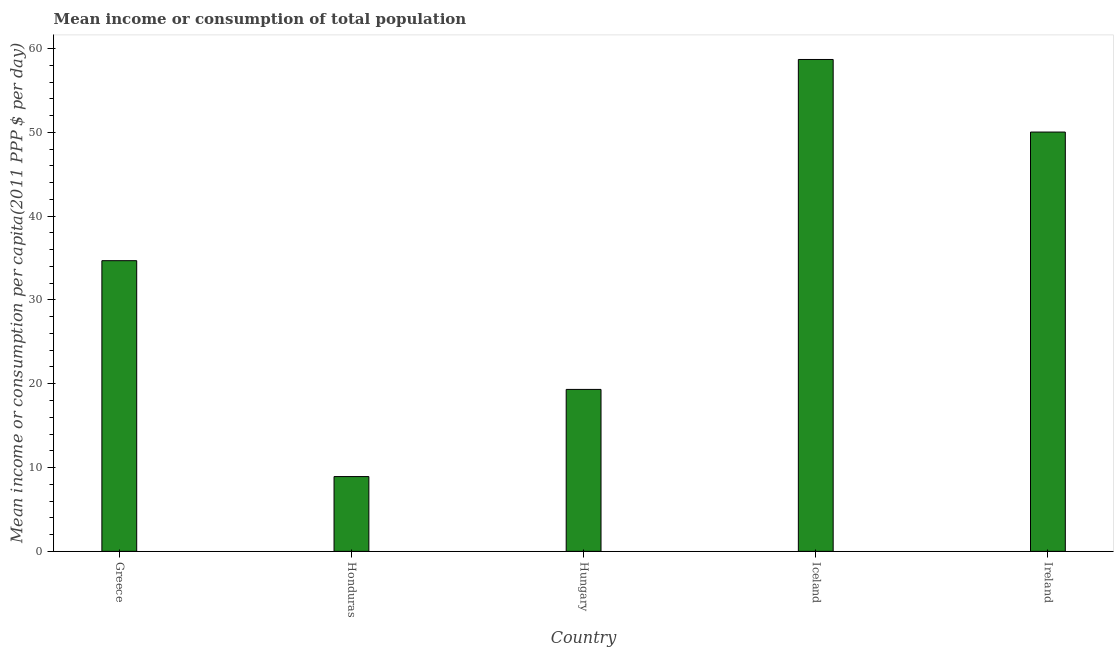What is the title of the graph?
Your answer should be compact. Mean income or consumption of total population. What is the label or title of the Y-axis?
Offer a very short reply. Mean income or consumption per capita(2011 PPP $ per day). What is the mean income or consumption in Honduras?
Your response must be concise. 8.92. Across all countries, what is the maximum mean income or consumption?
Make the answer very short. 58.69. Across all countries, what is the minimum mean income or consumption?
Offer a very short reply. 8.92. In which country was the mean income or consumption maximum?
Your answer should be very brief. Iceland. In which country was the mean income or consumption minimum?
Offer a very short reply. Honduras. What is the sum of the mean income or consumption?
Provide a short and direct response. 171.64. What is the difference between the mean income or consumption in Honduras and Hungary?
Provide a succinct answer. -10.4. What is the average mean income or consumption per country?
Offer a terse response. 34.33. What is the median mean income or consumption?
Your response must be concise. 34.68. What is the ratio of the mean income or consumption in Hungary to that in Ireland?
Your answer should be very brief. 0.39. Is the mean income or consumption in Greece less than that in Ireland?
Ensure brevity in your answer.  Yes. Is the difference between the mean income or consumption in Greece and Ireland greater than the difference between any two countries?
Offer a terse response. No. What is the difference between the highest and the second highest mean income or consumption?
Give a very brief answer. 8.66. Is the sum of the mean income or consumption in Iceland and Ireland greater than the maximum mean income or consumption across all countries?
Keep it short and to the point. Yes. What is the difference between the highest and the lowest mean income or consumption?
Offer a terse response. 49.77. Are all the bars in the graph horizontal?
Your response must be concise. No. How many countries are there in the graph?
Your answer should be compact. 5. Are the values on the major ticks of Y-axis written in scientific E-notation?
Offer a terse response. No. What is the Mean income or consumption per capita(2011 PPP $ per day) of Greece?
Offer a terse response. 34.68. What is the Mean income or consumption per capita(2011 PPP $ per day) in Honduras?
Ensure brevity in your answer.  8.92. What is the Mean income or consumption per capita(2011 PPP $ per day) of Hungary?
Provide a succinct answer. 19.32. What is the Mean income or consumption per capita(2011 PPP $ per day) in Iceland?
Offer a terse response. 58.69. What is the Mean income or consumption per capita(2011 PPP $ per day) in Ireland?
Ensure brevity in your answer.  50.03. What is the difference between the Mean income or consumption per capita(2011 PPP $ per day) in Greece and Honduras?
Your answer should be very brief. 25.76. What is the difference between the Mean income or consumption per capita(2011 PPP $ per day) in Greece and Hungary?
Your response must be concise. 15.36. What is the difference between the Mean income or consumption per capita(2011 PPP $ per day) in Greece and Iceland?
Your response must be concise. -24.01. What is the difference between the Mean income or consumption per capita(2011 PPP $ per day) in Greece and Ireland?
Offer a very short reply. -15.35. What is the difference between the Mean income or consumption per capita(2011 PPP $ per day) in Honduras and Hungary?
Your answer should be very brief. -10.4. What is the difference between the Mean income or consumption per capita(2011 PPP $ per day) in Honduras and Iceland?
Your answer should be compact. -49.77. What is the difference between the Mean income or consumption per capita(2011 PPP $ per day) in Honduras and Ireland?
Your response must be concise. -41.11. What is the difference between the Mean income or consumption per capita(2011 PPP $ per day) in Hungary and Iceland?
Provide a succinct answer. -39.37. What is the difference between the Mean income or consumption per capita(2011 PPP $ per day) in Hungary and Ireland?
Make the answer very short. -30.71. What is the difference between the Mean income or consumption per capita(2011 PPP $ per day) in Iceland and Ireland?
Offer a very short reply. 8.66. What is the ratio of the Mean income or consumption per capita(2011 PPP $ per day) in Greece to that in Honduras?
Provide a short and direct response. 3.89. What is the ratio of the Mean income or consumption per capita(2011 PPP $ per day) in Greece to that in Hungary?
Keep it short and to the point. 1.79. What is the ratio of the Mean income or consumption per capita(2011 PPP $ per day) in Greece to that in Iceland?
Keep it short and to the point. 0.59. What is the ratio of the Mean income or consumption per capita(2011 PPP $ per day) in Greece to that in Ireland?
Your response must be concise. 0.69. What is the ratio of the Mean income or consumption per capita(2011 PPP $ per day) in Honduras to that in Hungary?
Your answer should be compact. 0.46. What is the ratio of the Mean income or consumption per capita(2011 PPP $ per day) in Honduras to that in Iceland?
Provide a succinct answer. 0.15. What is the ratio of the Mean income or consumption per capita(2011 PPP $ per day) in Honduras to that in Ireland?
Your response must be concise. 0.18. What is the ratio of the Mean income or consumption per capita(2011 PPP $ per day) in Hungary to that in Iceland?
Keep it short and to the point. 0.33. What is the ratio of the Mean income or consumption per capita(2011 PPP $ per day) in Hungary to that in Ireland?
Provide a short and direct response. 0.39. What is the ratio of the Mean income or consumption per capita(2011 PPP $ per day) in Iceland to that in Ireland?
Offer a very short reply. 1.17. 